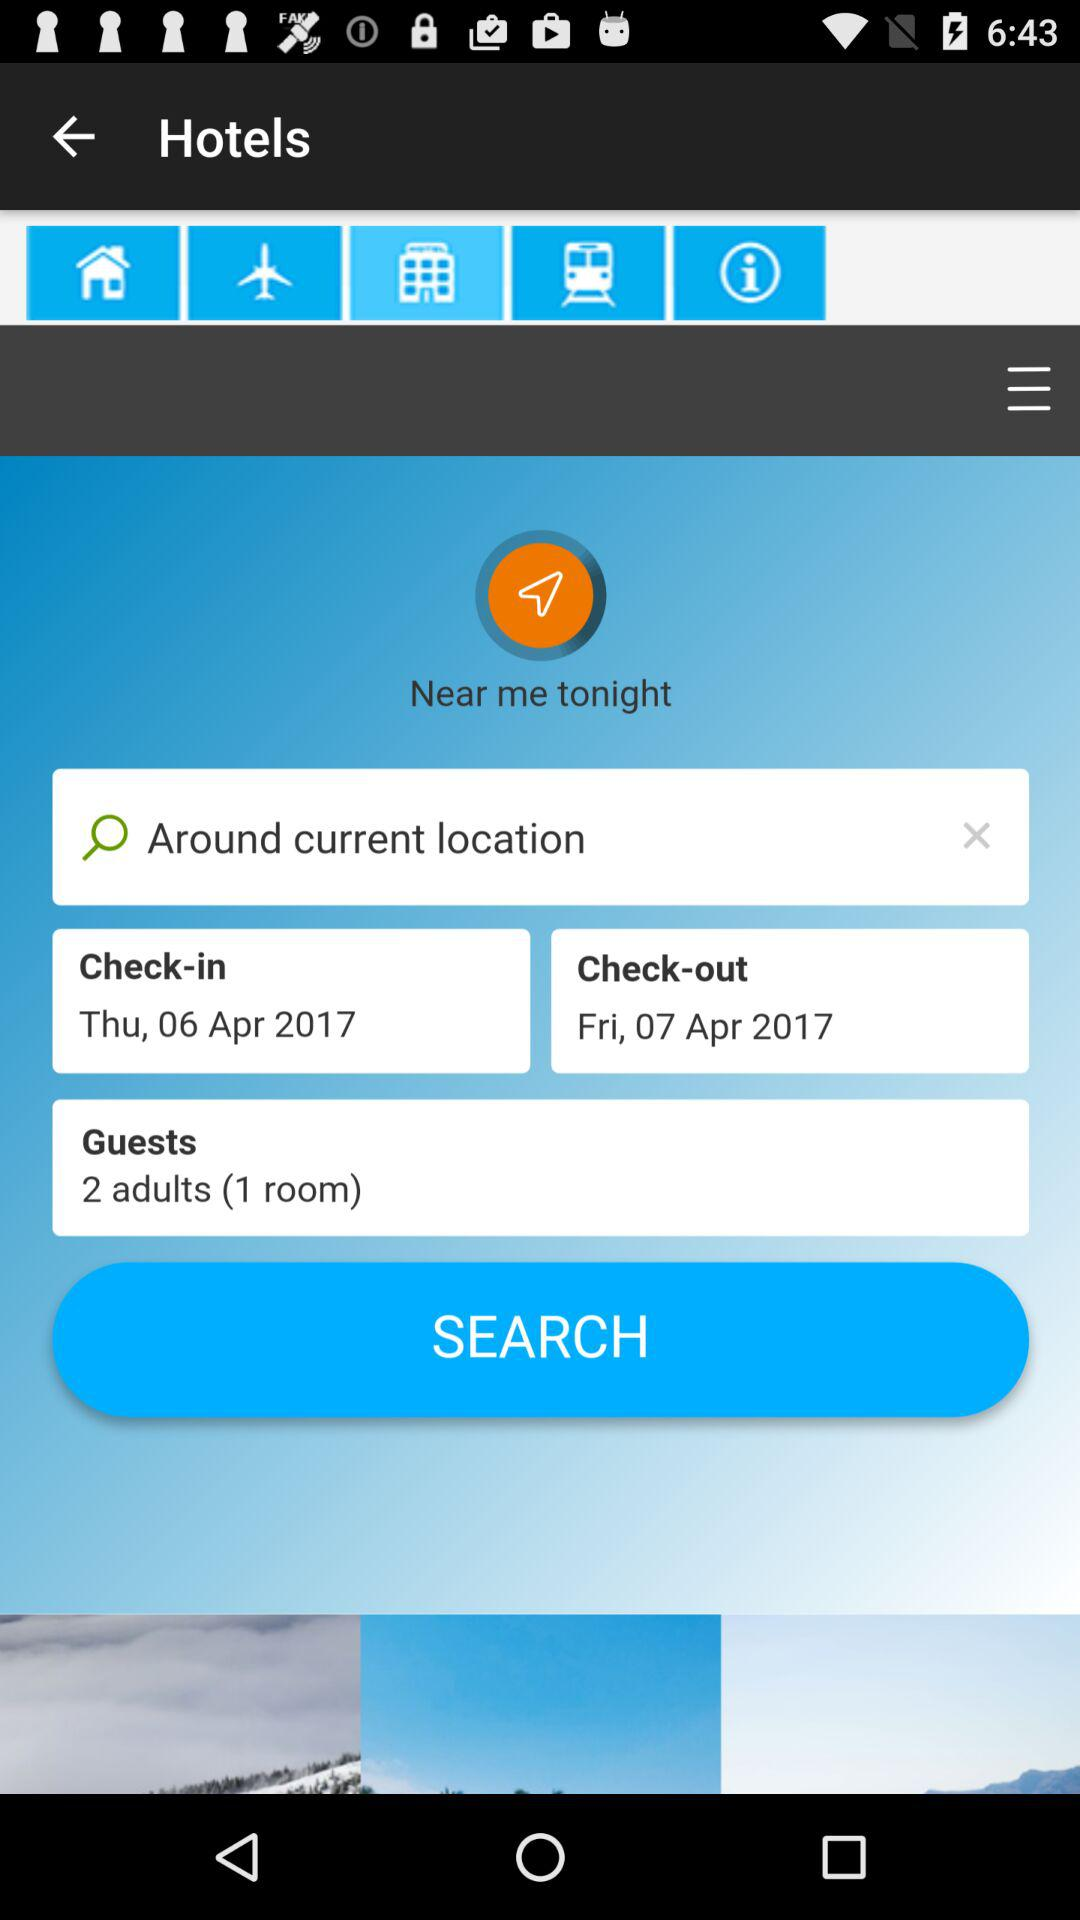What is the number of guests? The number of guests is 2. 